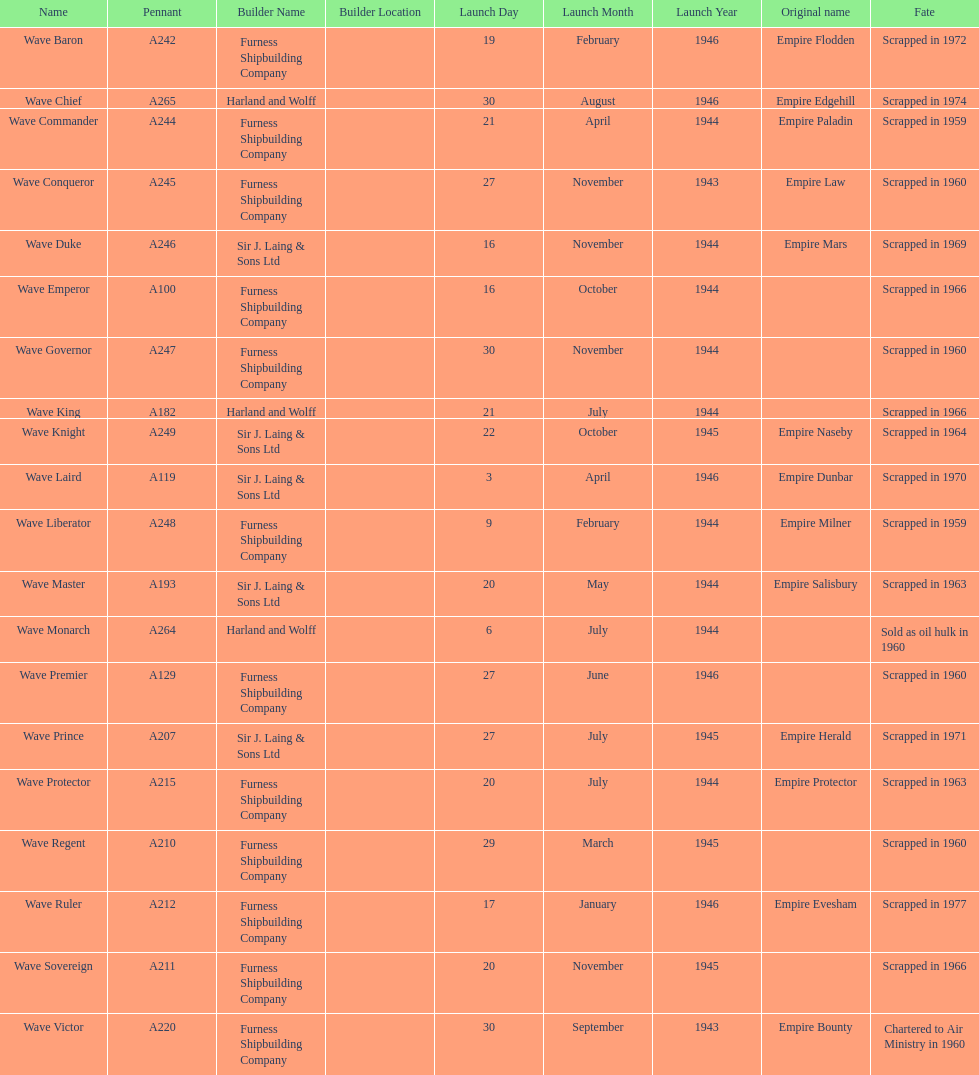What is the name of the last ship that was scrapped? Wave Ruler. 